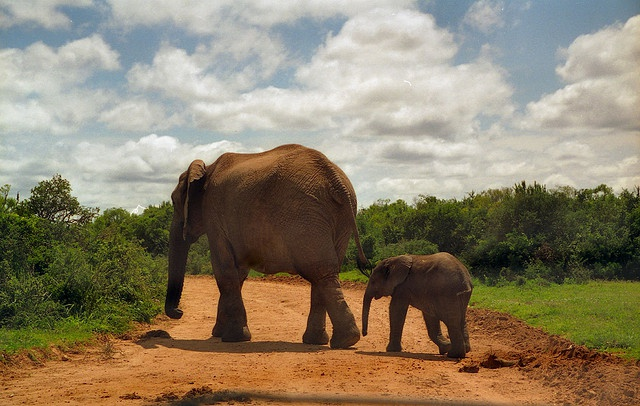Describe the objects in this image and their specific colors. I can see elephant in darkgray, black, maroon, and brown tones and elephant in darkgray, black, maroon, and gray tones in this image. 